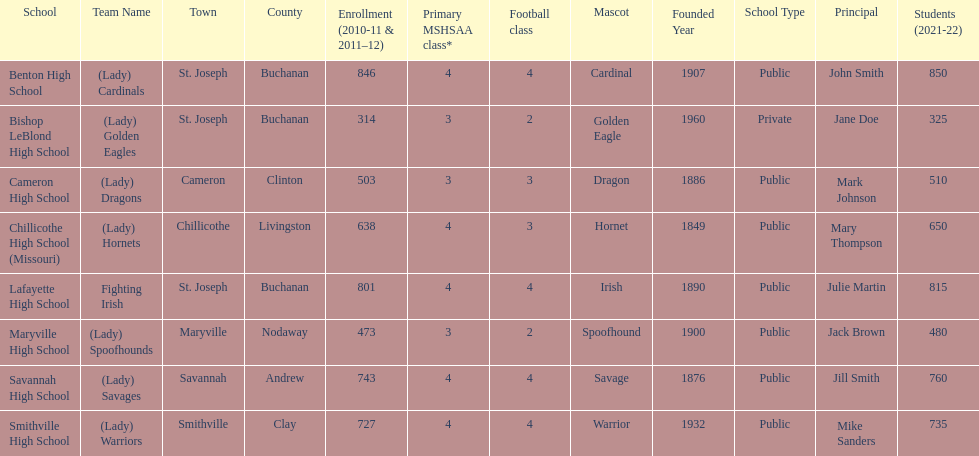What is the number of football classes lafayette high school has? 4. 